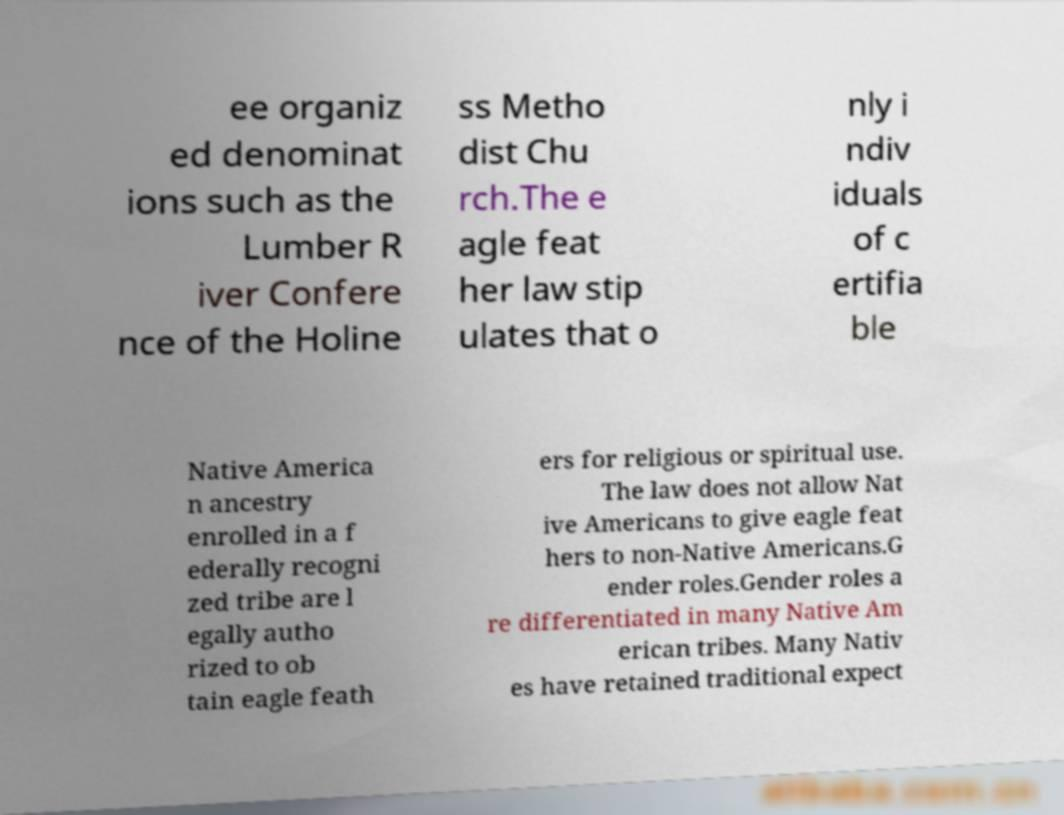Can you read and provide the text displayed in the image?This photo seems to have some interesting text. Can you extract and type it out for me? ee organiz ed denominat ions such as the Lumber R iver Confere nce of the Holine ss Metho dist Chu rch.The e agle feat her law stip ulates that o nly i ndiv iduals of c ertifia ble Native America n ancestry enrolled in a f ederally recogni zed tribe are l egally autho rized to ob tain eagle feath ers for religious or spiritual use. The law does not allow Nat ive Americans to give eagle feat hers to non-Native Americans.G ender roles.Gender roles a re differentiated in many Native Am erican tribes. Many Nativ es have retained traditional expect 